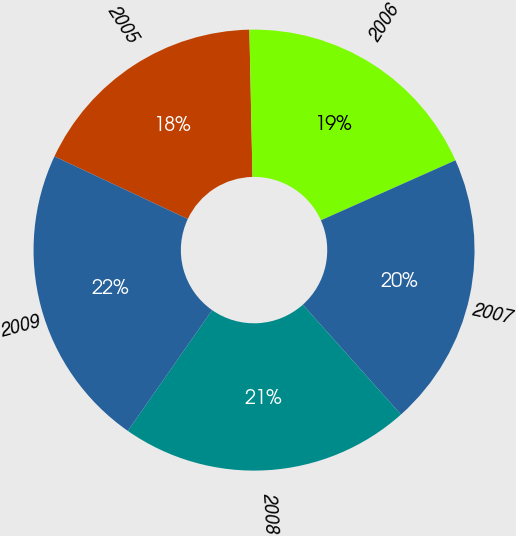Convert chart to OTSL. <chart><loc_0><loc_0><loc_500><loc_500><pie_chart><fcel>2005<fcel>2006<fcel>2007<fcel>2008<fcel>2009<nl><fcel>17.68%<fcel>18.66%<fcel>20.07%<fcel>21.3%<fcel>22.28%<nl></chart> 